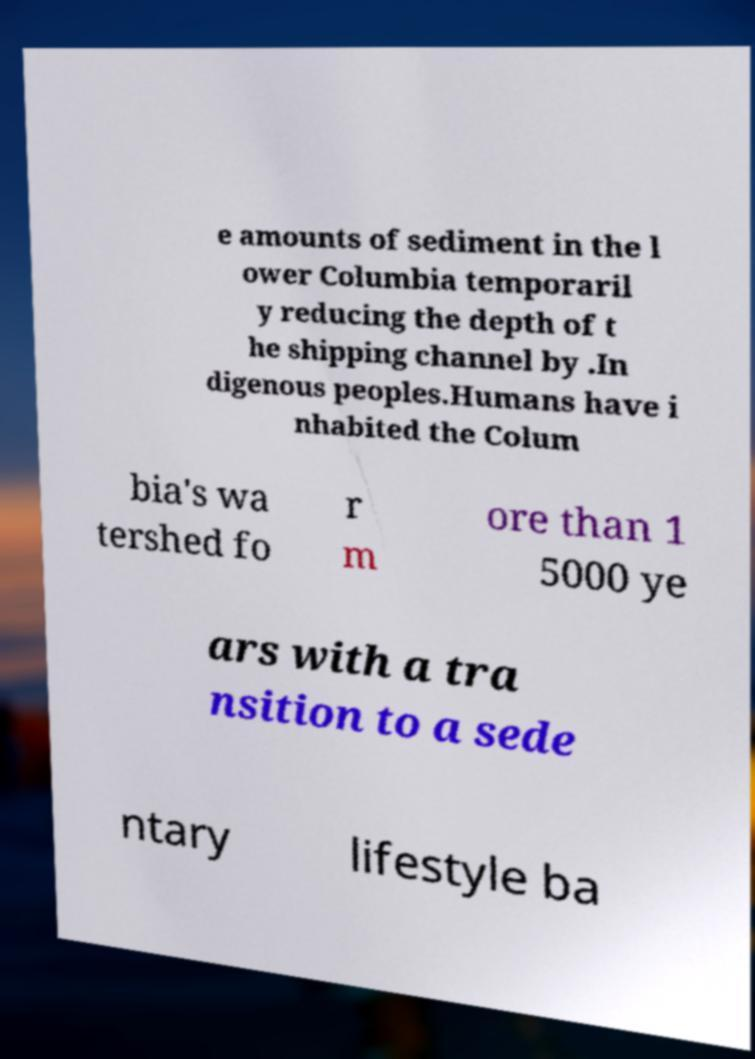What messages or text are displayed in this image? I need them in a readable, typed format. e amounts of sediment in the l ower Columbia temporaril y reducing the depth of t he shipping channel by .In digenous peoples.Humans have i nhabited the Colum bia's wa tershed fo r m ore than 1 5000 ye ars with a tra nsition to a sede ntary lifestyle ba 